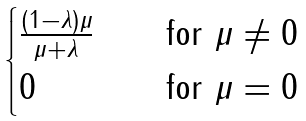Convert formula to latex. <formula><loc_0><loc_0><loc_500><loc_500>\begin{cases} \frac { ( 1 - \lambda ) \mu } { \mu + \lambda } \quad & \text {for } \mu \ne 0 \\ 0 & \text {for } \mu = 0 \end{cases}</formula> 